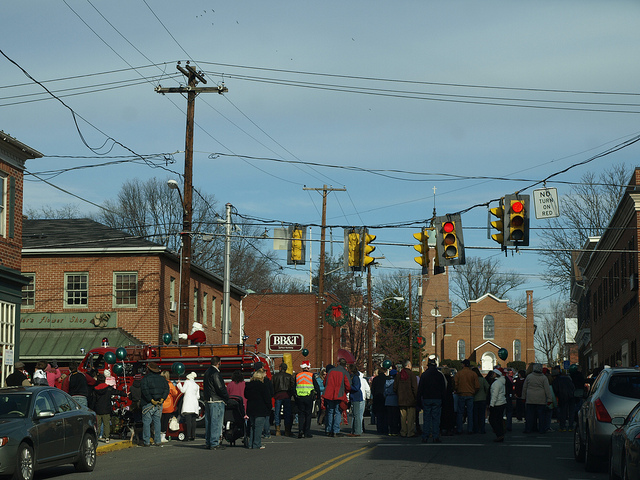<image>Who is the man standing next to the truck? It is unknown who the man standing next to the truck is. It is not possible to tell from the information provided. What color is the van? I don't know. It can be gray, silver, white or red. What color is the van? It is unanswerable what color is the van as it can't be seen in the image. Who is the man standing next to the truck? I don't know who the man standing next to the truck is. He can be a crossing guard, mayor, dad, Tim, street crossing guard with Santa hat, police, spectator, unknown, or fireman. 